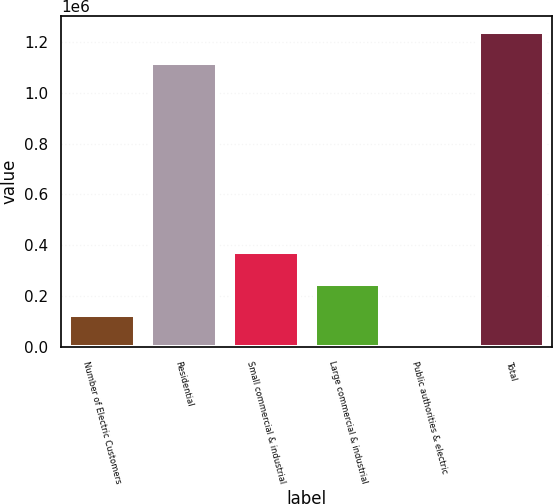<chart> <loc_0><loc_0><loc_500><loc_500><bar_chart><fcel>Number of Electric Customers<fcel>Residential<fcel>Small commercial & industrial<fcel>Large commercial & industrial<fcel>Public authorities & electric<fcel>Total<nl><fcel>124400<fcel>1.11623e+06<fcel>372561<fcel>248480<fcel>319<fcel>1.24113e+06<nl></chart> 